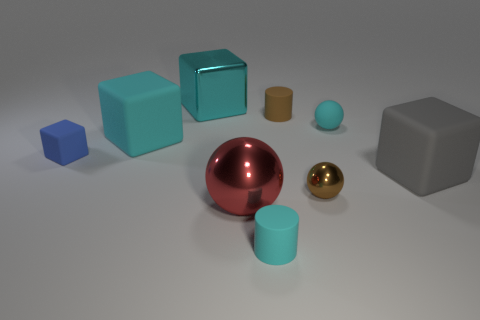Is the color of the tiny cylinder that is behind the small brown metal thing the same as the shiny thing that is right of the brown rubber thing?
Offer a very short reply. Yes. There is a blue object that is the same size as the brown rubber cylinder; what shape is it?
Keep it short and to the point. Cube. How many things are cyan objects on the left side of the cyan shiny object or small blue rubber cubes?
Your response must be concise. 2. There is a big block on the right side of the large red object that is behind the tiny cyan matte cylinder; is there a red metallic ball on the left side of it?
Your answer should be very brief. Yes. What number of tiny blue rubber blocks are there?
Provide a short and direct response. 1. How many things are cyan rubber objects in front of the gray rubber cube or balls that are behind the red shiny thing?
Your answer should be very brief. 3. Does the matte cylinder that is behind the gray thing have the same size as the tiny cube?
Offer a very short reply. Yes. There is a cyan matte object that is the same shape as the blue thing; what is its size?
Keep it short and to the point. Large. There is a sphere that is the same size as the metallic block; what material is it?
Give a very brief answer. Metal. There is a tiny cyan object that is the same shape as the brown shiny object; what is its material?
Provide a succinct answer. Rubber. 